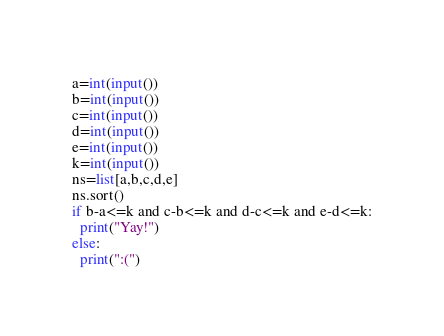<code> <loc_0><loc_0><loc_500><loc_500><_Python_>a=int(input())
b=int(input())
c=int(input())
d=int(input())
e=int(input())
k=int(input())
ns=list[a,b,c,d,e]
ns.sort()
if b-a<=k and c-b<=k and d-c<=k and e-d<=k:
  print("Yay!")
else:
  print(":(")</code> 